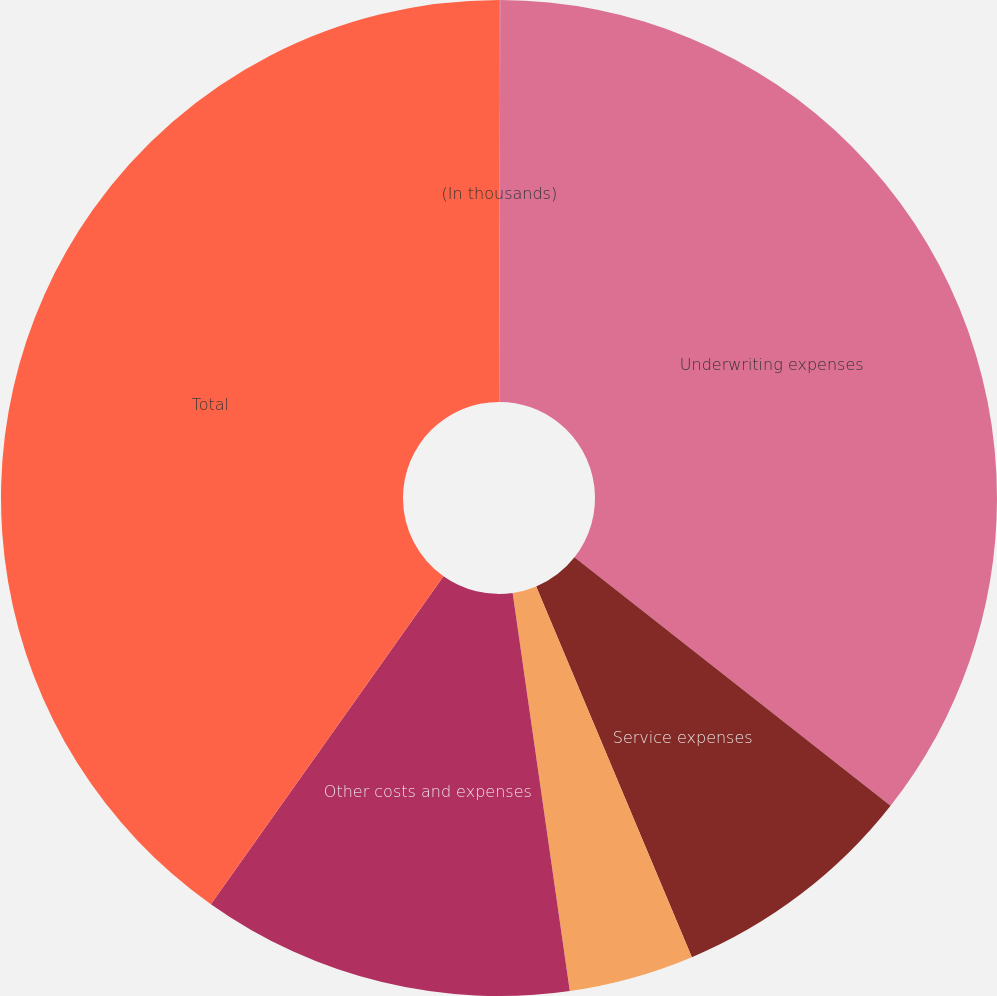Convert chart to OTSL. <chart><loc_0><loc_0><loc_500><loc_500><pie_chart><fcel>(In thousands)<fcel>Underwriting expenses<fcel>Service expenses<fcel>Net foreign currency gains<fcel>Other costs and expenses<fcel>Total<nl><fcel>0.04%<fcel>35.56%<fcel>8.07%<fcel>4.06%<fcel>12.09%<fcel>40.18%<nl></chart> 